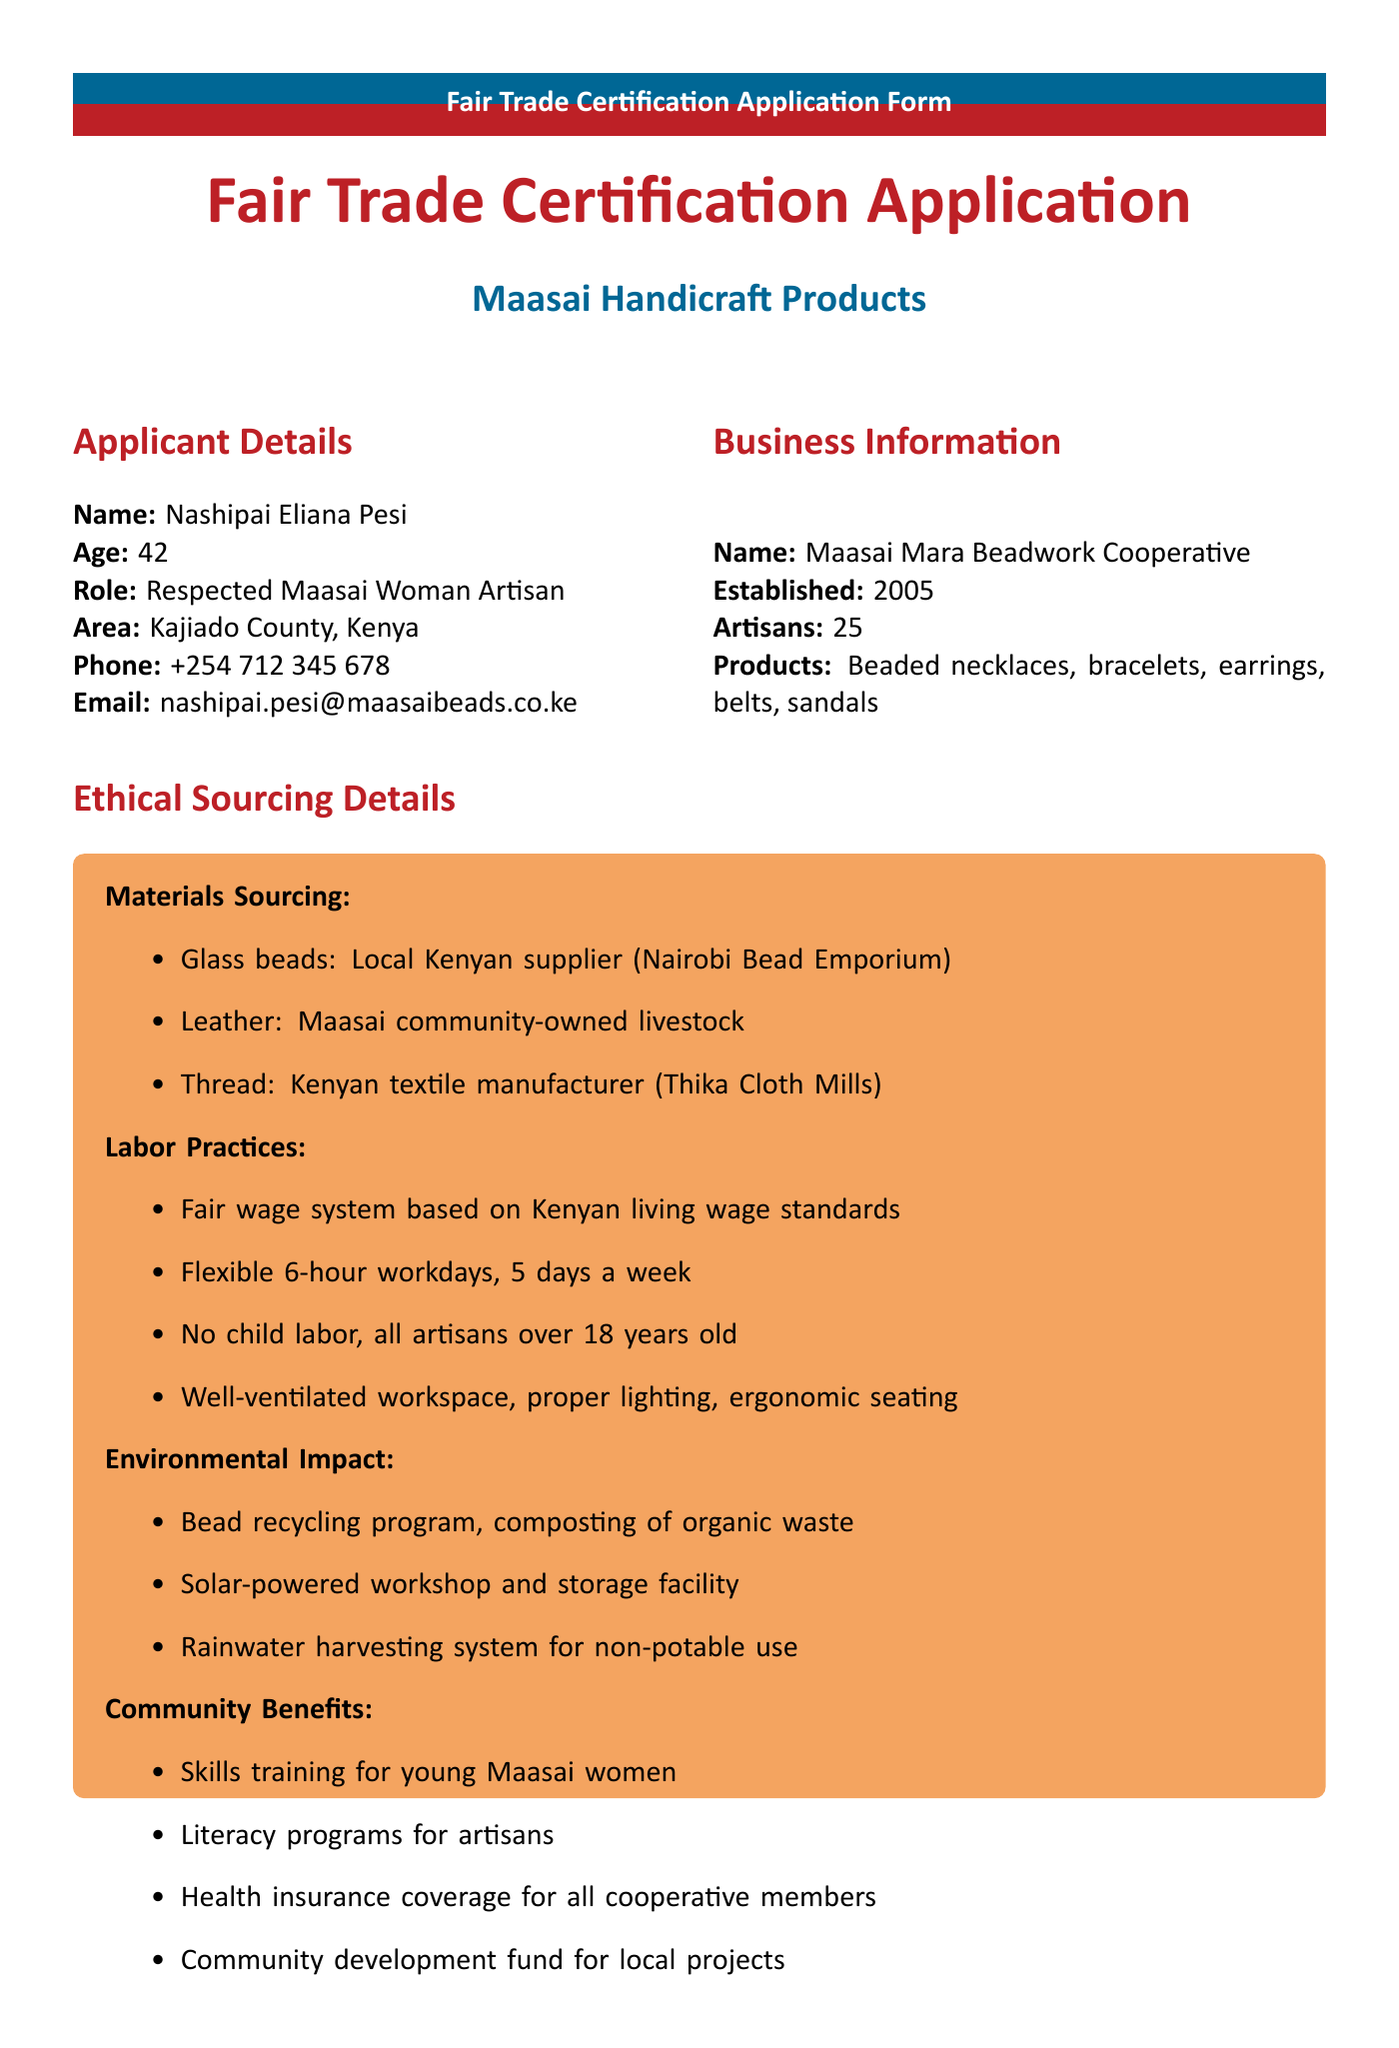what is the full name of the applicant? The application form lists the full name of the applicant in the details section.
Answer: Nashipai Eliana Pesi in what year was the Maasai Mara Beadwork Cooperative established? The year of establishment is stated under the business information section of the form.
Answer: 2005 how many artisans are part of the cooperative? The number of artisans is specified in the business information section.
Answer: 25 what is one of the materials sourced from the Maasai community? The ethical sourcing details mention materials and their sources.
Answer: Leather how many beaded earrings are produced monthly? The production capacity section provides the monthly output for different products including earrings.
Answer: 1000 what type of workspace safety measure is mentioned? The document provides specific information on labor practices, including safety measures.
Answer: Well-ventilated workspace what is the reason for seeking Fair Trade certification? The document clearly states the reason for applying for Fair Trade certification under the certification history section.
Answer: To expand market reach, ensure fair compensation for artisans, and promote Maasai cultural heritage globally what type of programs does the cooperative offer to young Maasai women? Community benefits are listed in the ethical sourcing section which includes initiatives for young women.
Answer: Skills training which certification was obtained in 2010? Previous certifications and their corresponding years are detailed in the certification history section.
Answer: Kenya Bureau of Standards (KEBS) Quality Mark 